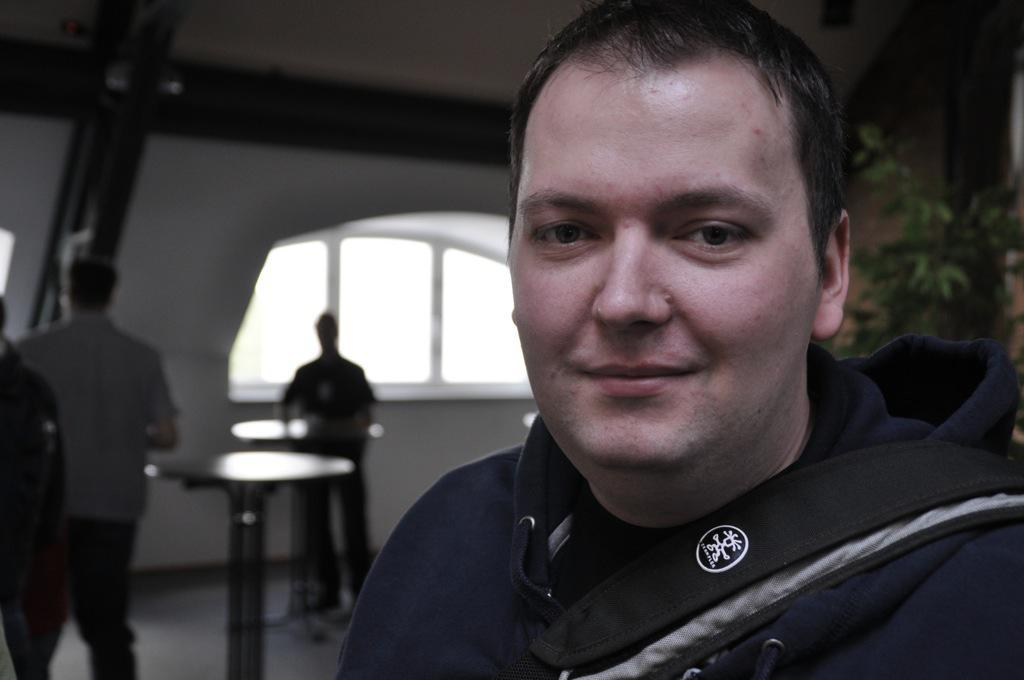What is the man in the image wearing? The man in the image is wearing a blue jacket. How many people are standing in the image? There are two persons standing in the image. What is present in the image that might be used for holding objects? There is a table in the image. What type of vegetation can be seen in the image? There is a plant in the image. What type of structure is visible in the image? There is a wall in the image. What type of jeans can be seen hanging from the wall in the image? There are no jeans present in the image; only a man in a blue jacket, two persons standing, a table, a plant, and a wall are visible. 